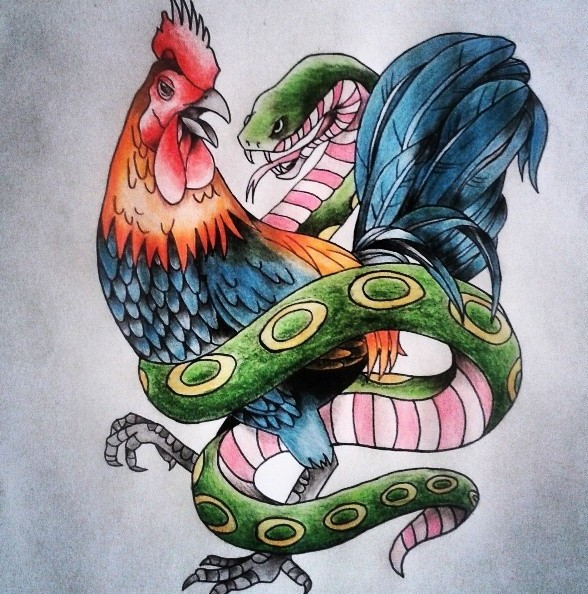Observe the way the snake's body curls around the rooster in this image. What does this say about their relationship? The way the snake's body curls around the rooster may indicate an intimate, albeit complex, relationship. It suggests a form of entanglement where one cannot exist without the other, representing dependency or co-existence. The snake enveloping the rooster could symbolize protection, constriction, or a dance of power and dominion. This depiction can invoke a sense of tension and a delicate balance within their relationship, emphasizing that their interaction is both competitive and synergistic. Could this also imply a predatory interaction? Yes, it could certainly imply a predatory interaction. The snake might be seen as seeking to dominate or consume the rooster, illustrating a predator-prey dynamic. This layer adds intensity to their depiction, reflecting the harsh realities of nature and survival. However, the rooster's staunch stance and vibrant plumage suggest resilience and defiance, creating a gripping visual narrative of a battle for survival and dominance. 